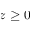Convert formula to latex. <formula><loc_0><loc_0><loc_500><loc_500>z \geq 0</formula> 